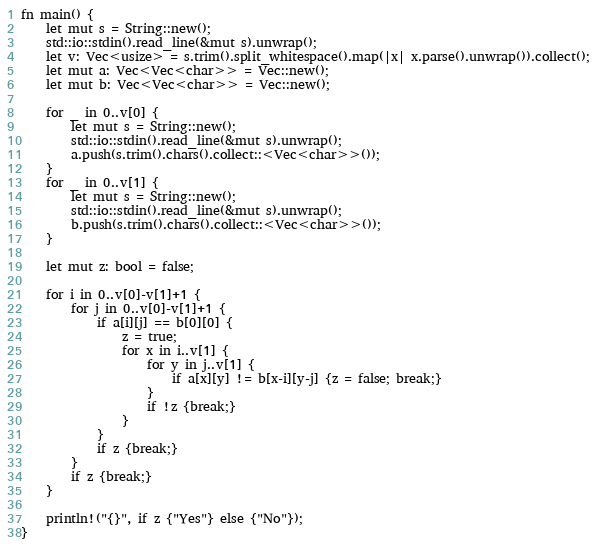<code> <loc_0><loc_0><loc_500><loc_500><_Rust_>fn main() {
    let mut s = String::new();
    std::io::stdin().read_line(&mut s).unwrap();
    let v: Vec<usize> = s.trim().split_whitespace().map(|x| x.parse().unwrap()).collect();
    let mut a: Vec<Vec<char>> = Vec::new();
    let mut b: Vec<Vec<char>> = Vec::new();

    for _ in 0..v[0] {
        let mut s = String::new();
        std::io::stdin().read_line(&mut s).unwrap();
        a.push(s.trim().chars().collect::<Vec<char>>());
    }
    for _ in 0..v[1] {
        let mut s = String::new();
        std::io::stdin().read_line(&mut s).unwrap();
        b.push(s.trim().chars().collect::<Vec<char>>());
    }

    let mut z: bool = false;

    for i in 0..v[0]-v[1]+1 {
        for j in 0..v[0]-v[1]+1 {
            if a[i][j] == b[0][0] {
                z = true;
                for x in i..v[1] {
                    for y in j..v[1] {
                        if a[x][y] != b[x-i][y-j] {z = false; break;}
                    }
                    if !z {break;}
                }
            }
            if z {break;}
        }
        if z {break;}
    }

    println!("{}", if z {"Yes"} else {"No"});
}

</code> 